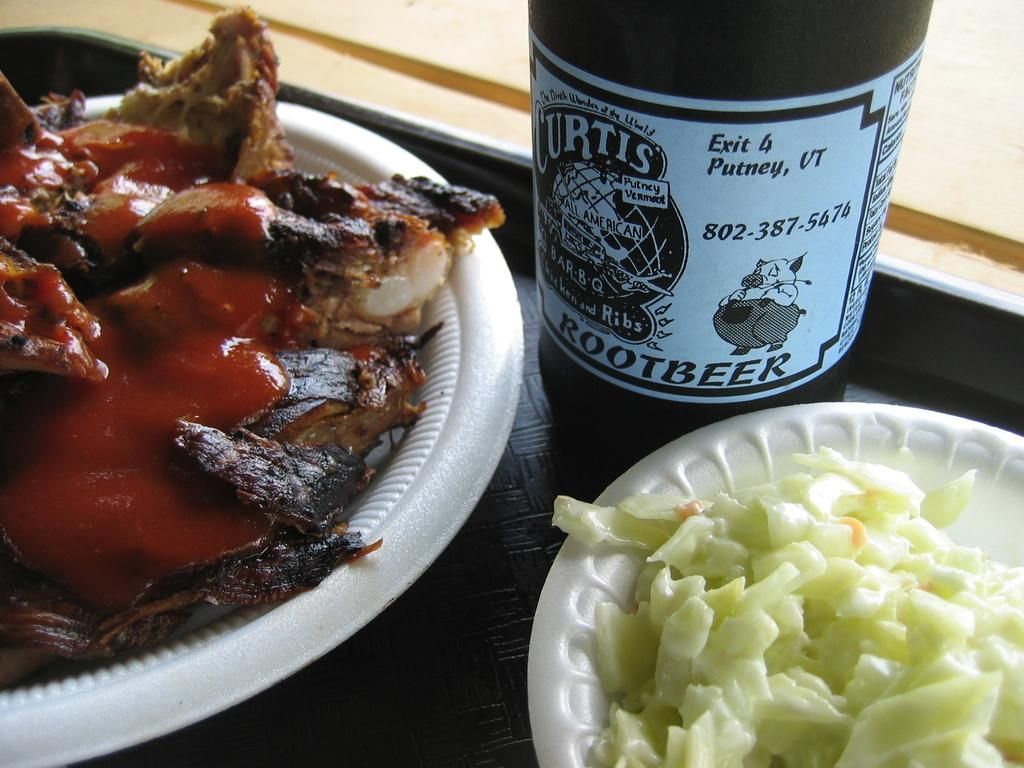What type of items can be seen in the image? There are food items in the image. How many plates are there in the image? The food items are on two plates. What color are the plates? The plates are white in color. What else can be seen in the image besides the food items and plates? There is a beer bottle in the image. Where is the beer bottle located? The beer bottle is in a tray. What color is the tray? The tray is black in color. What type of pancake can be smelled in the image? There is no pancake present in the image, and therefore no smell can be associated with it. Are there any birds visible in the image? There are no birds visible in the image. 